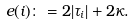Convert formula to latex. <formula><loc_0><loc_0><loc_500><loc_500>\ e ( i ) \colon = 2 | \tau _ { i } | + 2 \kappa .</formula> 